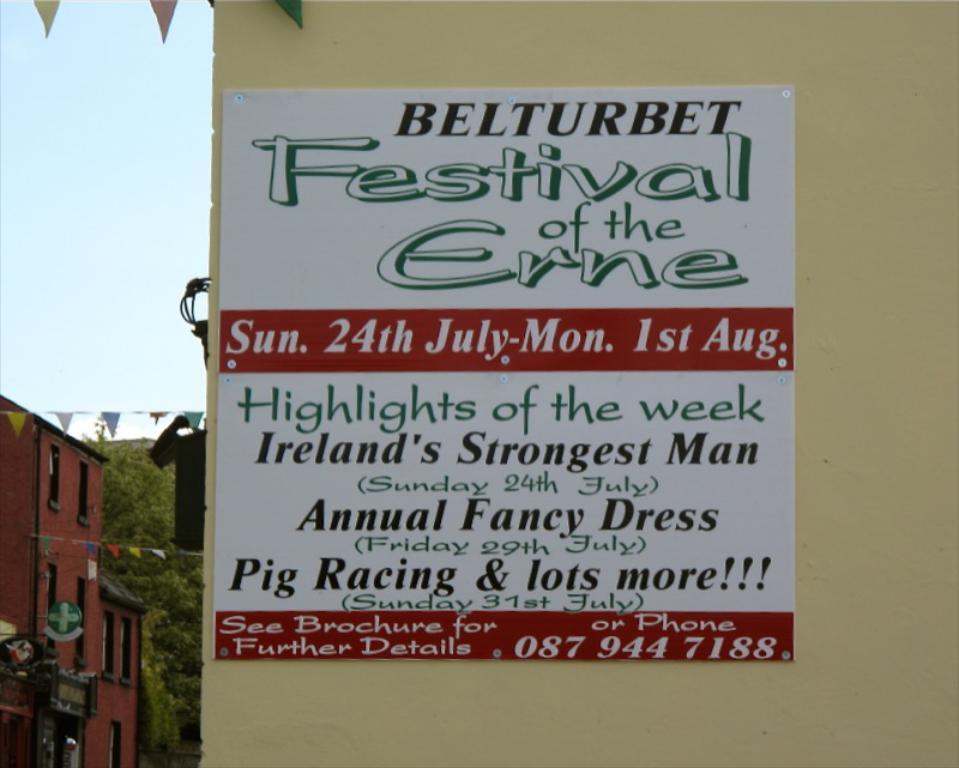Please provide a concise description of this image. In this picture there is a poster on the wall, in the poster there is a text. On the left side of the image there is a building and tree and there is a board on the building. At the top there is sky and there are flags. 